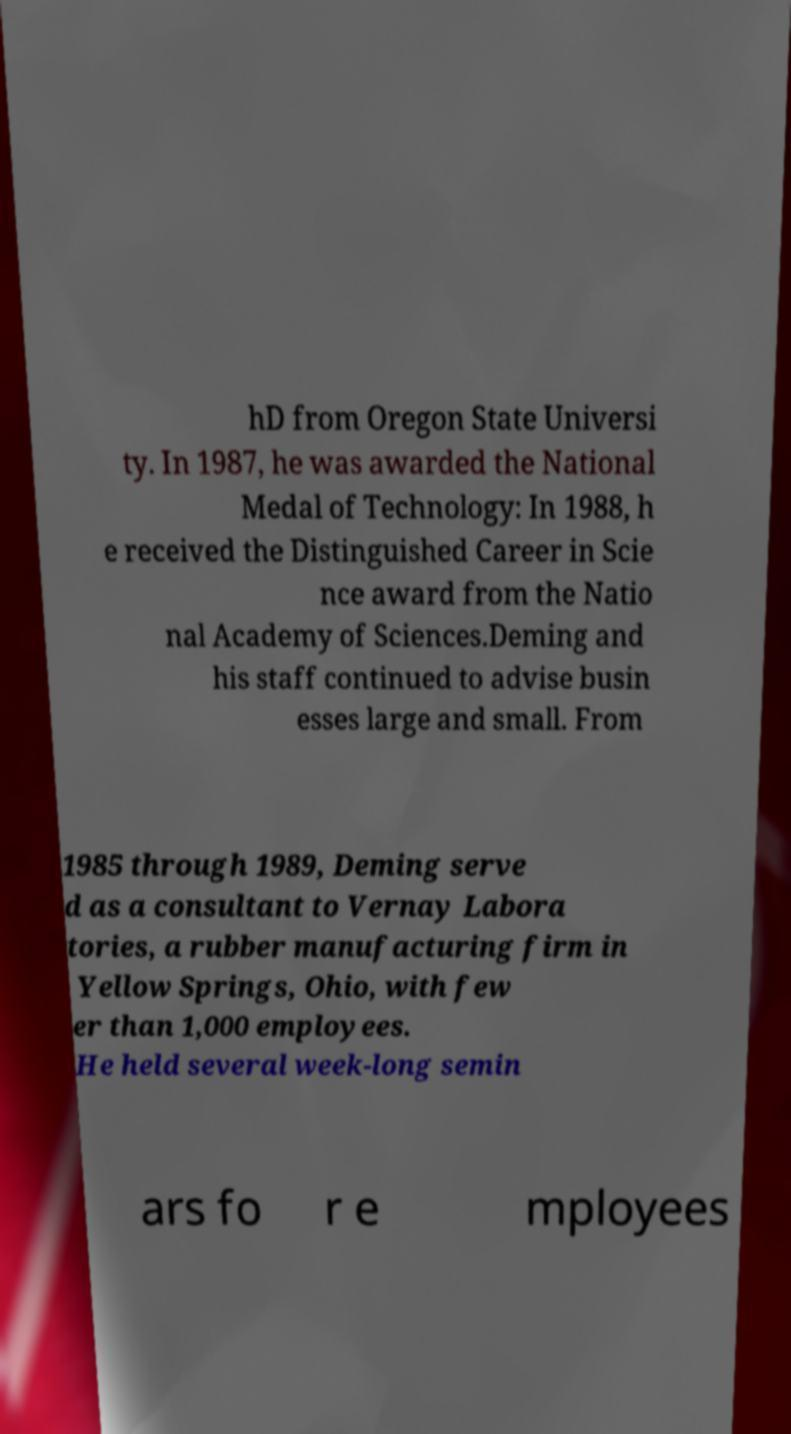Please read and relay the text visible in this image. What does it say? hD from Oregon State Universi ty. In 1987, he was awarded the National Medal of Technology: In 1988, h e received the Distinguished Career in Scie nce award from the Natio nal Academy of Sciences.Deming and his staff continued to advise busin esses large and small. From 1985 through 1989, Deming serve d as a consultant to Vernay Labora tories, a rubber manufacturing firm in Yellow Springs, Ohio, with few er than 1,000 employees. He held several week-long semin ars fo r e mployees 